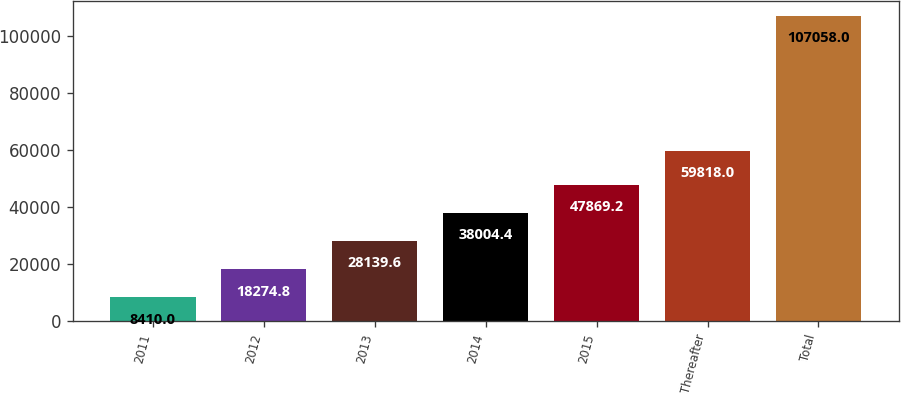Convert chart to OTSL. <chart><loc_0><loc_0><loc_500><loc_500><bar_chart><fcel>2011<fcel>2012<fcel>2013<fcel>2014<fcel>2015<fcel>Thereafter<fcel>Total<nl><fcel>8410<fcel>18274.8<fcel>28139.6<fcel>38004.4<fcel>47869.2<fcel>59818<fcel>107058<nl></chart> 